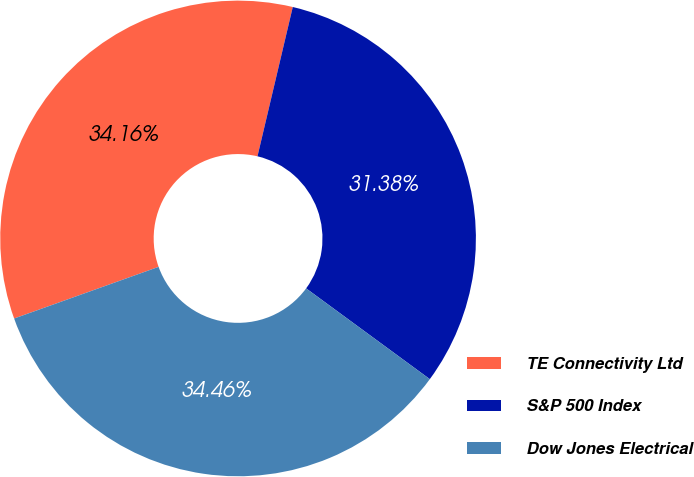<chart> <loc_0><loc_0><loc_500><loc_500><pie_chart><fcel>TE Connectivity Ltd<fcel>S&P 500 Index<fcel>Dow Jones Electrical<nl><fcel>34.16%<fcel>31.38%<fcel>34.46%<nl></chart> 